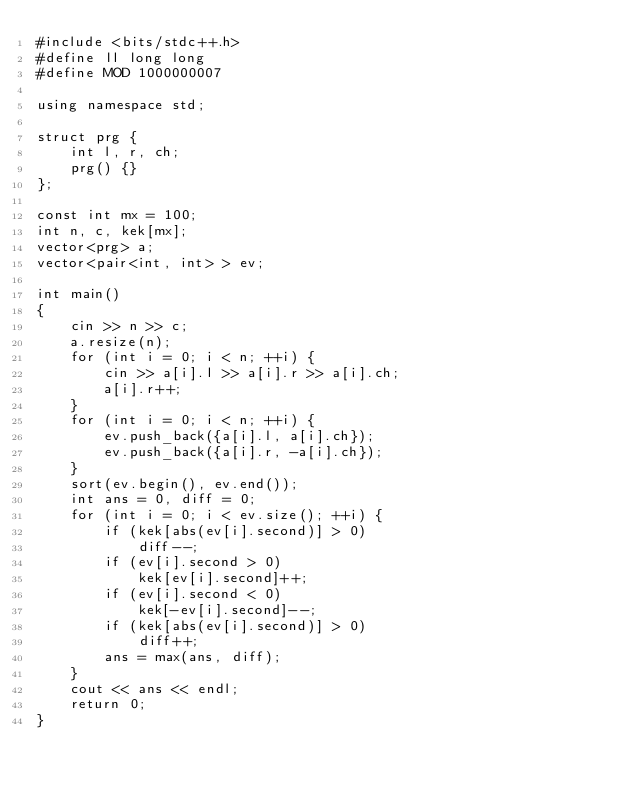<code> <loc_0><loc_0><loc_500><loc_500><_C++_>#include <bits/stdc++.h>
#define ll long long
#define MOD 1000000007

using namespace std;

struct prg {
    int l, r, ch;
    prg() {}
};

const int mx = 100;
int n, c, kek[mx];
vector<prg> a;
vector<pair<int, int> > ev;

int main()
{
    cin >> n >> c;
    a.resize(n);
    for (int i = 0; i < n; ++i) {
        cin >> a[i].l >> a[i].r >> a[i].ch;
        a[i].r++;
    }
    for (int i = 0; i < n; ++i) {
        ev.push_back({a[i].l, a[i].ch});
        ev.push_back({a[i].r, -a[i].ch});
    }
    sort(ev.begin(), ev.end());
    int ans = 0, diff = 0;
    for (int i = 0; i < ev.size(); ++i) {
        if (kek[abs(ev[i].second)] > 0)
            diff--;
        if (ev[i].second > 0)
            kek[ev[i].second]++;
        if (ev[i].second < 0)
            kek[-ev[i].second]--;
        if (kek[abs(ev[i].second)] > 0)
            diff++;
        ans = max(ans, diff);
    }
    cout << ans << endl;
    return 0;
}
</code> 